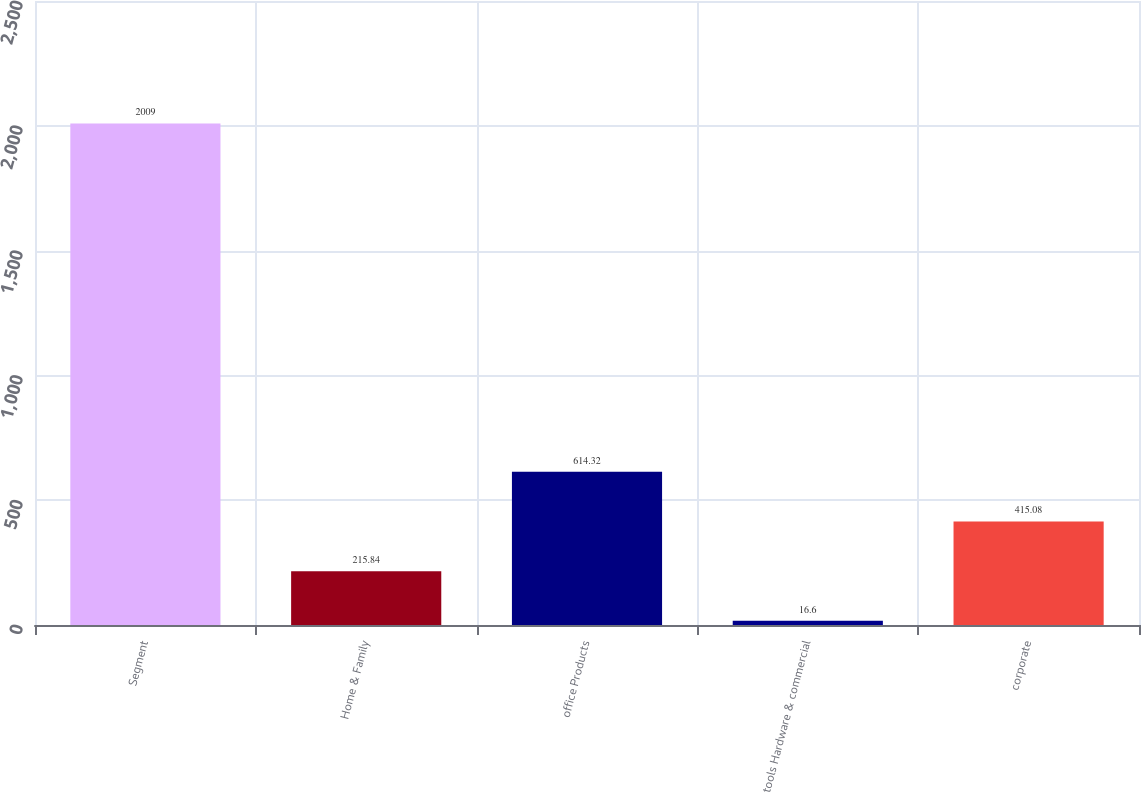Convert chart to OTSL. <chart><loc_0><loc_0><loc_500><loc_500><bar_chart><fcel>Segment<fcel>Home & Family<fcel>office Products<fcel>tools Hardware & commercial<fcel>corporate<nl><fcel>2009<fcel>215.84<fcel>614.32<fcel>16.6<fcel>415.08<nl></chart> 